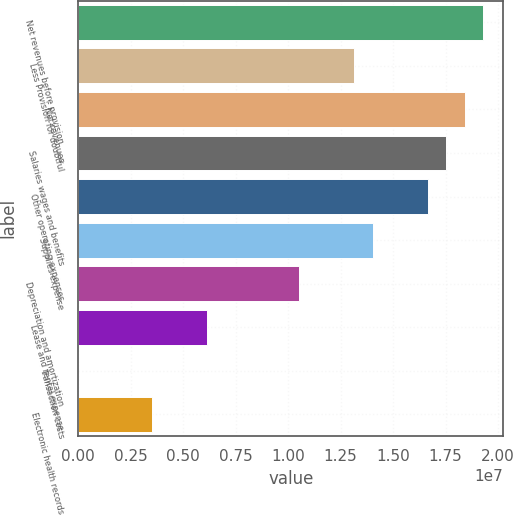<chart> <loc_0><loc_0><loc_500><loc_500><bar_chart><fcel>Net revenues before provision<fcel>Less Provision for doubtful<fcel>Net revenues<fcel>Salaries wages and benefits<fcel>Other operating expenses<fcel>Supplies expense<fcel>Depreciation and amortization<fcel>Lease and rental expense<fcel>Transaction costs<fcel>Electronic health records<nl><fcel>1.92815e+07<fcel>1.31465e+07<fcel>1.8405e+07<fcel>1.75286e+07<fcel>1.66522e+07<fcel>1.40229e+07<fcel>1.05172e+07<fcel>6.13502e+06<fcel>3.6<fcel>3.50573e+06<nl></chart> 